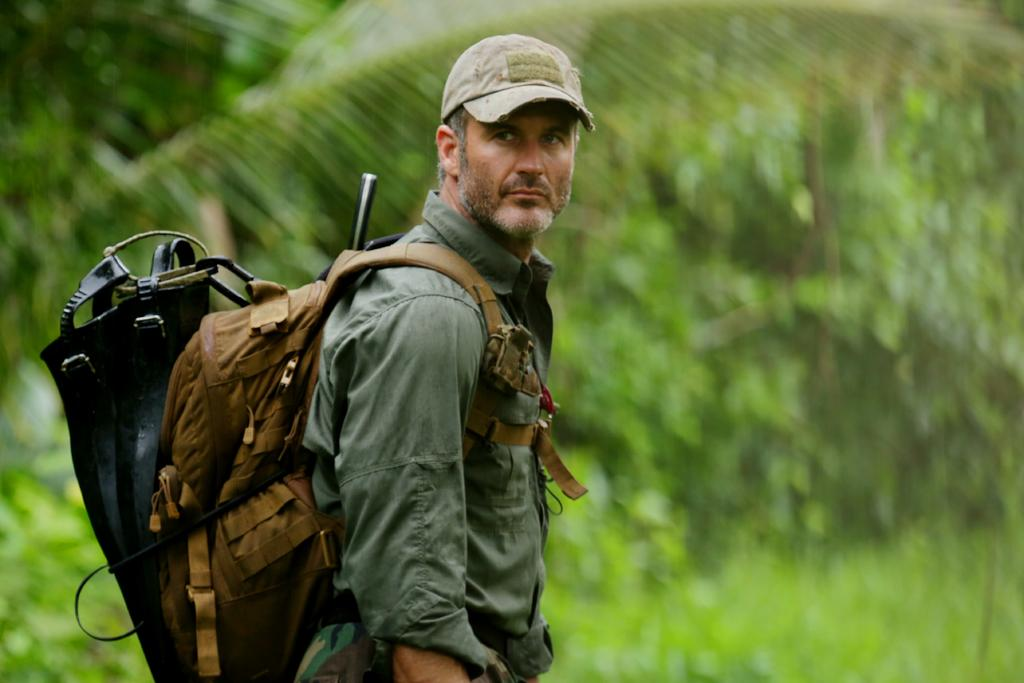Who or what is present in the image? There is a person in the image. What is the person wearing on their body? The person is wearing a bag and a cap. What can be seen in the background of the image? There are trees in the background of the image. What type of goose can be seen playing with the person in the image? There is no goose present in the image; it only features a person wearing a bag and a cap, with trees in the background. 